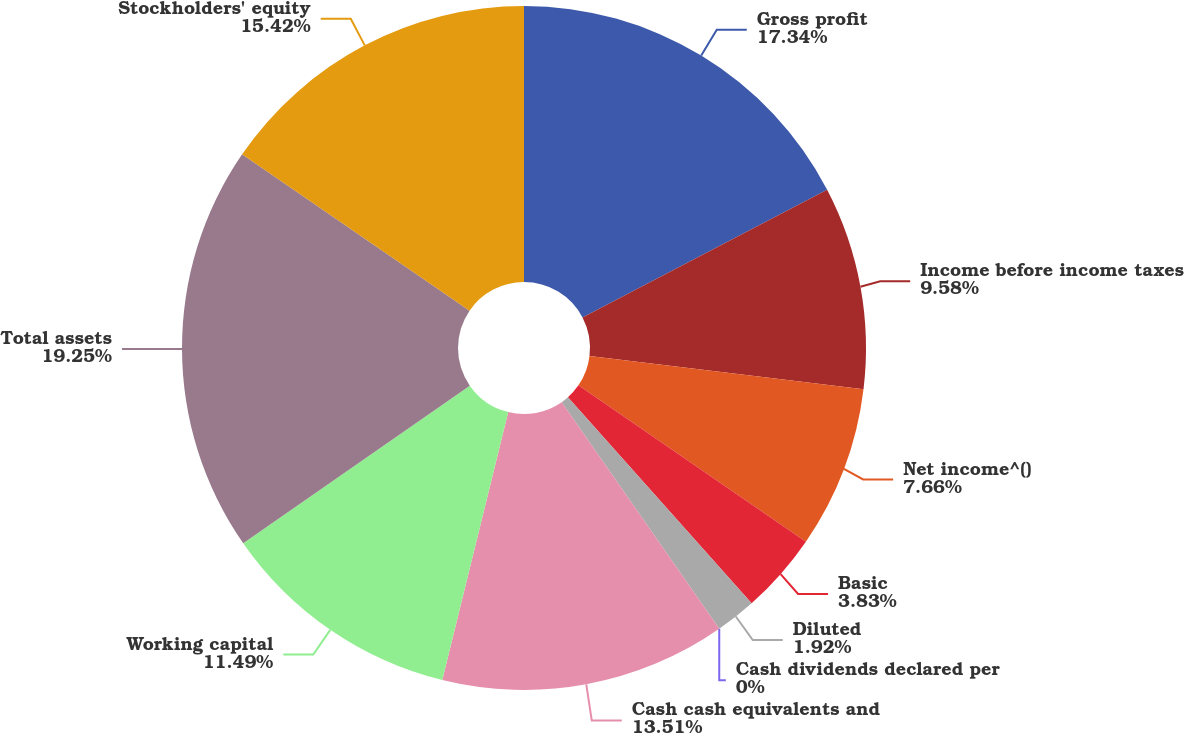<chart> <loc_0><loc_0><loc_500><loc_500><pie_chart><fcel>Gross profit<fcel>Income before income taxes<fcel>Net income^()<fcel>Basic<fcel>Diluted<fcel>Cash dividends declared per<fcel>Cash cash equivalents and<fcel>Working capital<fcel>Total assets<fcel>Stockholders' equity<nl><fcel>17.34%<fcel>9.58%<fcel>7.66%<fcel>3.83%<fcel>1.92%<fcel>0.0%<fcel>13.51%<fcel>11.49%<fcel>19.25%<fcel>15.42%<nl></chart> 